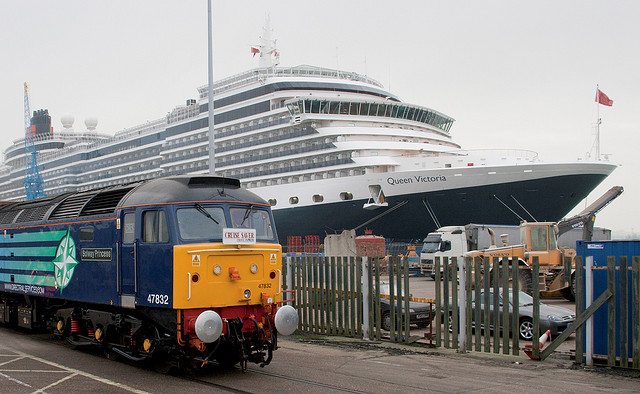<image>What is the number on the train? I am not sure about the number on the train. It could be '47832' or '47332'. Who owns this train? It is not known who owns the train. It can be 'United States', 'Serenity Princess', 'CSX', 'Bowey Process', or 'Cruise Sister'. What is the number on the train? The number on the train is 47832. Who owns this train? It is unknown who owns this train. 